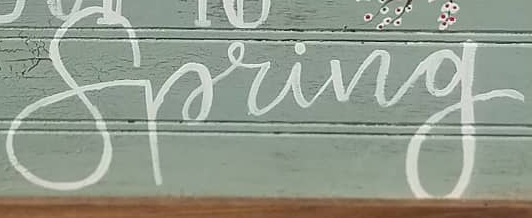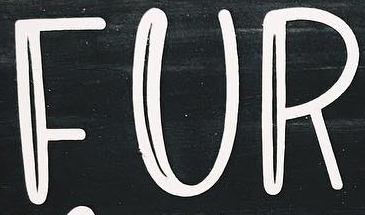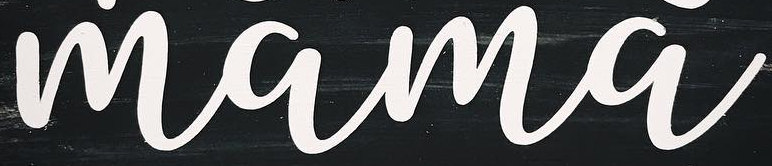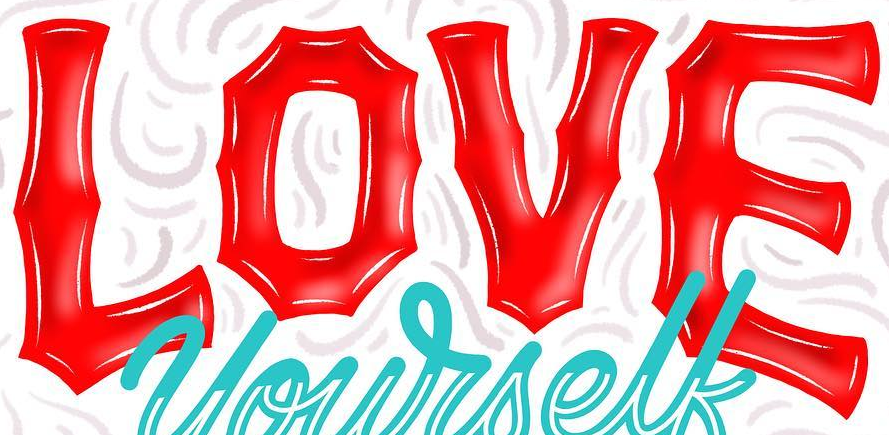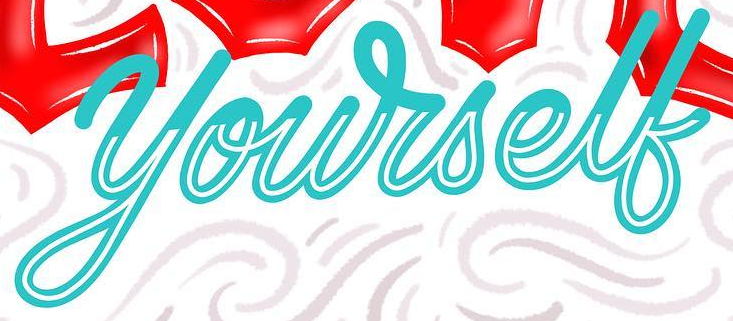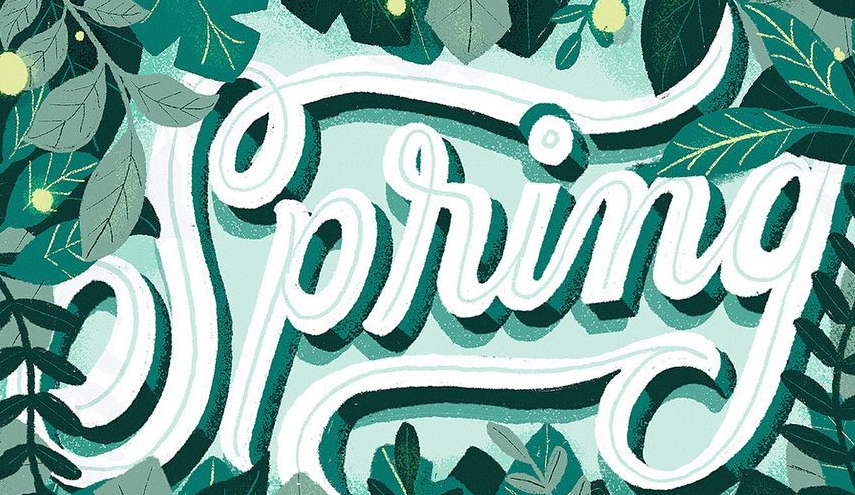What words can you see in these images in sequence, separated by a semicolon? Spring; FUR; mama; LOVE; yourself; Spring 